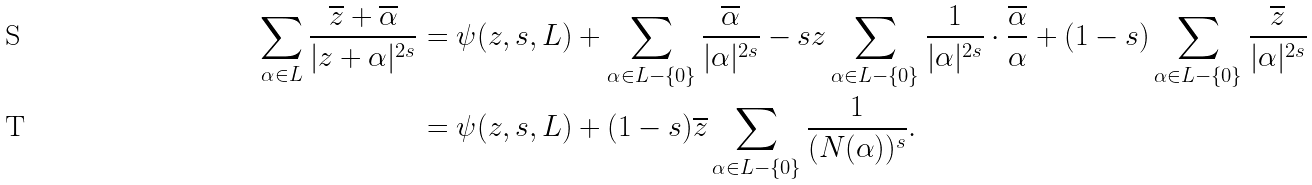Convert formula to latex. <formula><loc_0><loc_0><loc_500><loc_500>\sum _ { \alpha \in L } \frac { \overline { z } + \overline { \alpha } } { | z + \alpha | ^ { 2 s } } & = \psi ( z , s , L ) + \sum _ { \alpha \in L - \{ 0 \} } \frac { \overline { \alpha } } { | \alpha | ^ { 2 s } } - s z \sum _ { \alpha \in L - \{ 0 \} } \frac { 1 } { | \alpha | ^ { 2 s } } \cdot \frac { \overline { \alpha } } { \alpha } + ( 1 - s ) \sum _ { \alpha \in L - \{ 0 \} } \frac { \overline { z } } { | \alpha | ^ { 2 s } } \\ & = \psi ( z , s , L ) + ( 1 - s ) \overline { z } \sum _ { \alpha \in L - \{ 0 \} } \frac { 1 } { ( N ( \alpha ) ) ^ { s } } .</formula> 